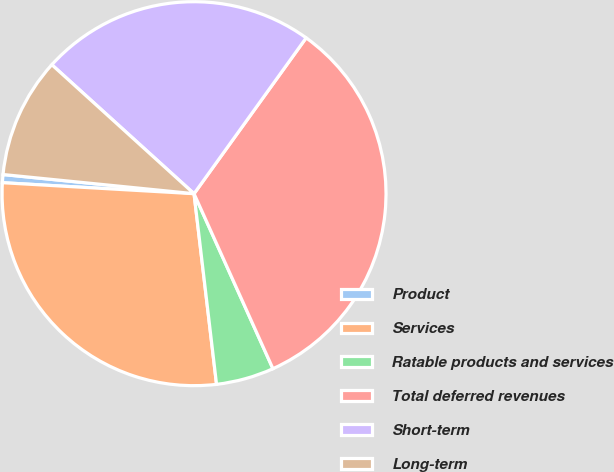Convert chart. <chart><loc_0><loc_0><loc_500><loc_500><pie_chart><fcel>Product<fcel>Services<fcel>Ratable products and services<fcel>Total deferred revenues<fcel>Short-term<fcel>Long-term<nl><fcel>0.68%<fcel>27.78%<fcel>4.87%<fcel>33.33%<fcel>23.2%<fcel>10.13%<nl></chart> 